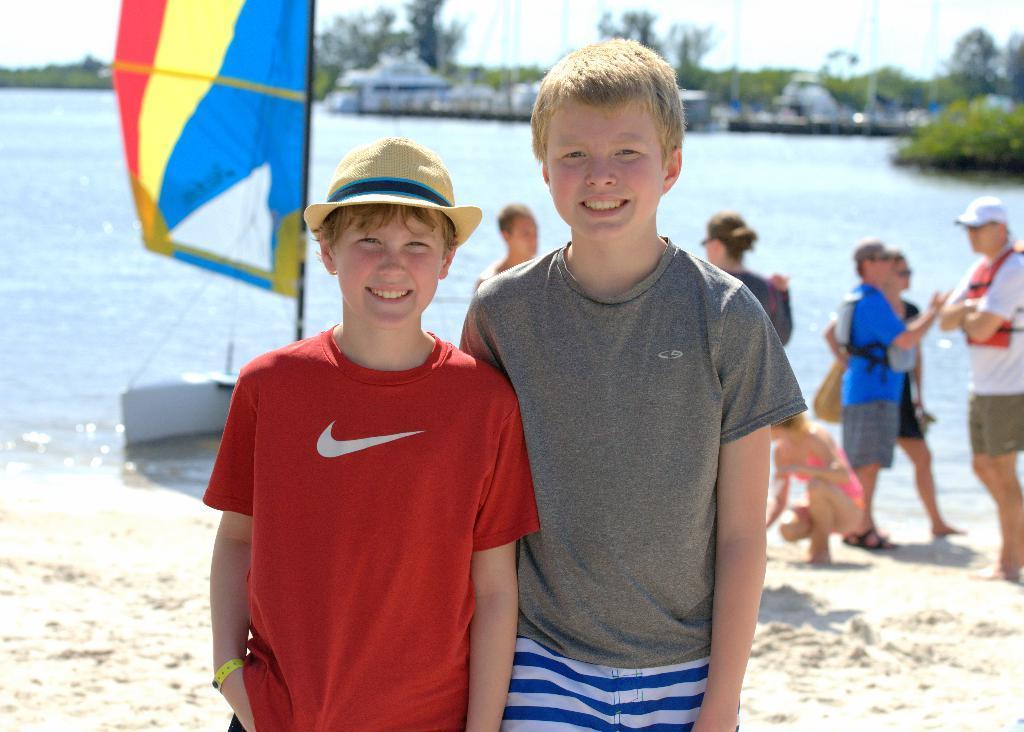Can you describe this image briefly? In this image I can see some people. I can see a boat on the water. In the background, I can see the houses, trees and the sky. 